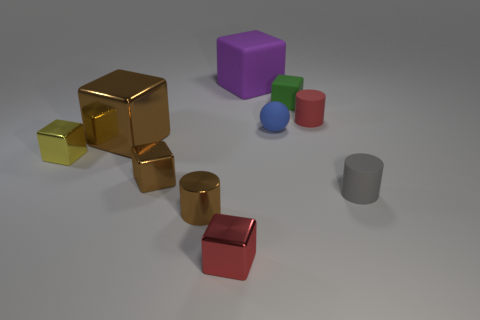Subtract all big purple cubes. How many cubes are left? 5 Subtract all balls. How many objects are left? 9 Subtract 2 cylinders. How many cylinders are left? 1 Subtract all gray cylinders. Subtract all red spheres. How many cylinders are left? 2 Subtract all red cubes. How many gray cylinders are left? 1 Subtract all small red metal spheres. Subtract all red matte objects. How many objects are left? 9 Add 2 purple cubes. How many purple cubes are left? 3 Add 8 big cyan matte objects. How many big cyan matte objects exist? 8 Subtract all purple blocks. How many blocks are left? 5 Subtract 0 blue cubes. How many objects are left? 10 